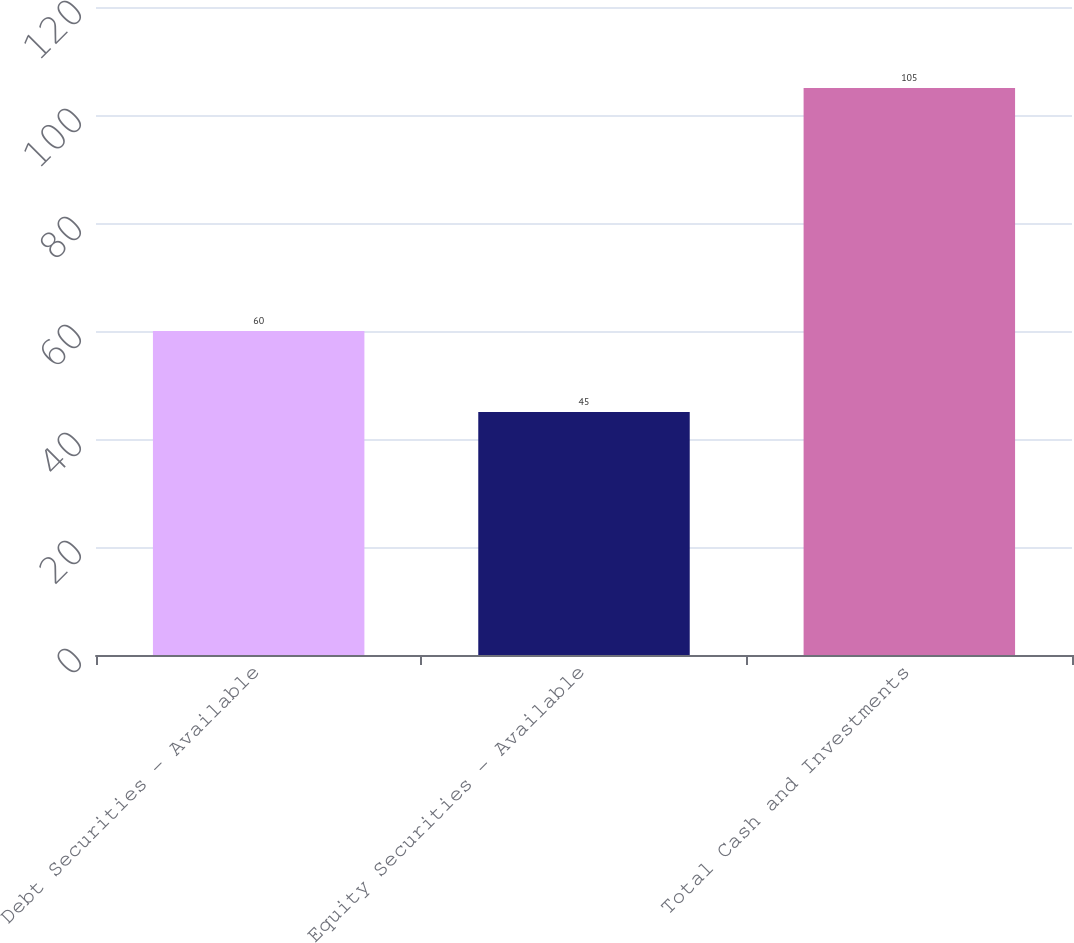Convert chart. <chart><loc_0><loc_0><loc_500><loc_500><bar_chart><fcel>Debt Securities - Available<fcel>Equity Securities - Available<fcel>Total Cash and Investments<nl><fcel>60<fcel>45<fcel>105<nl></chart> 